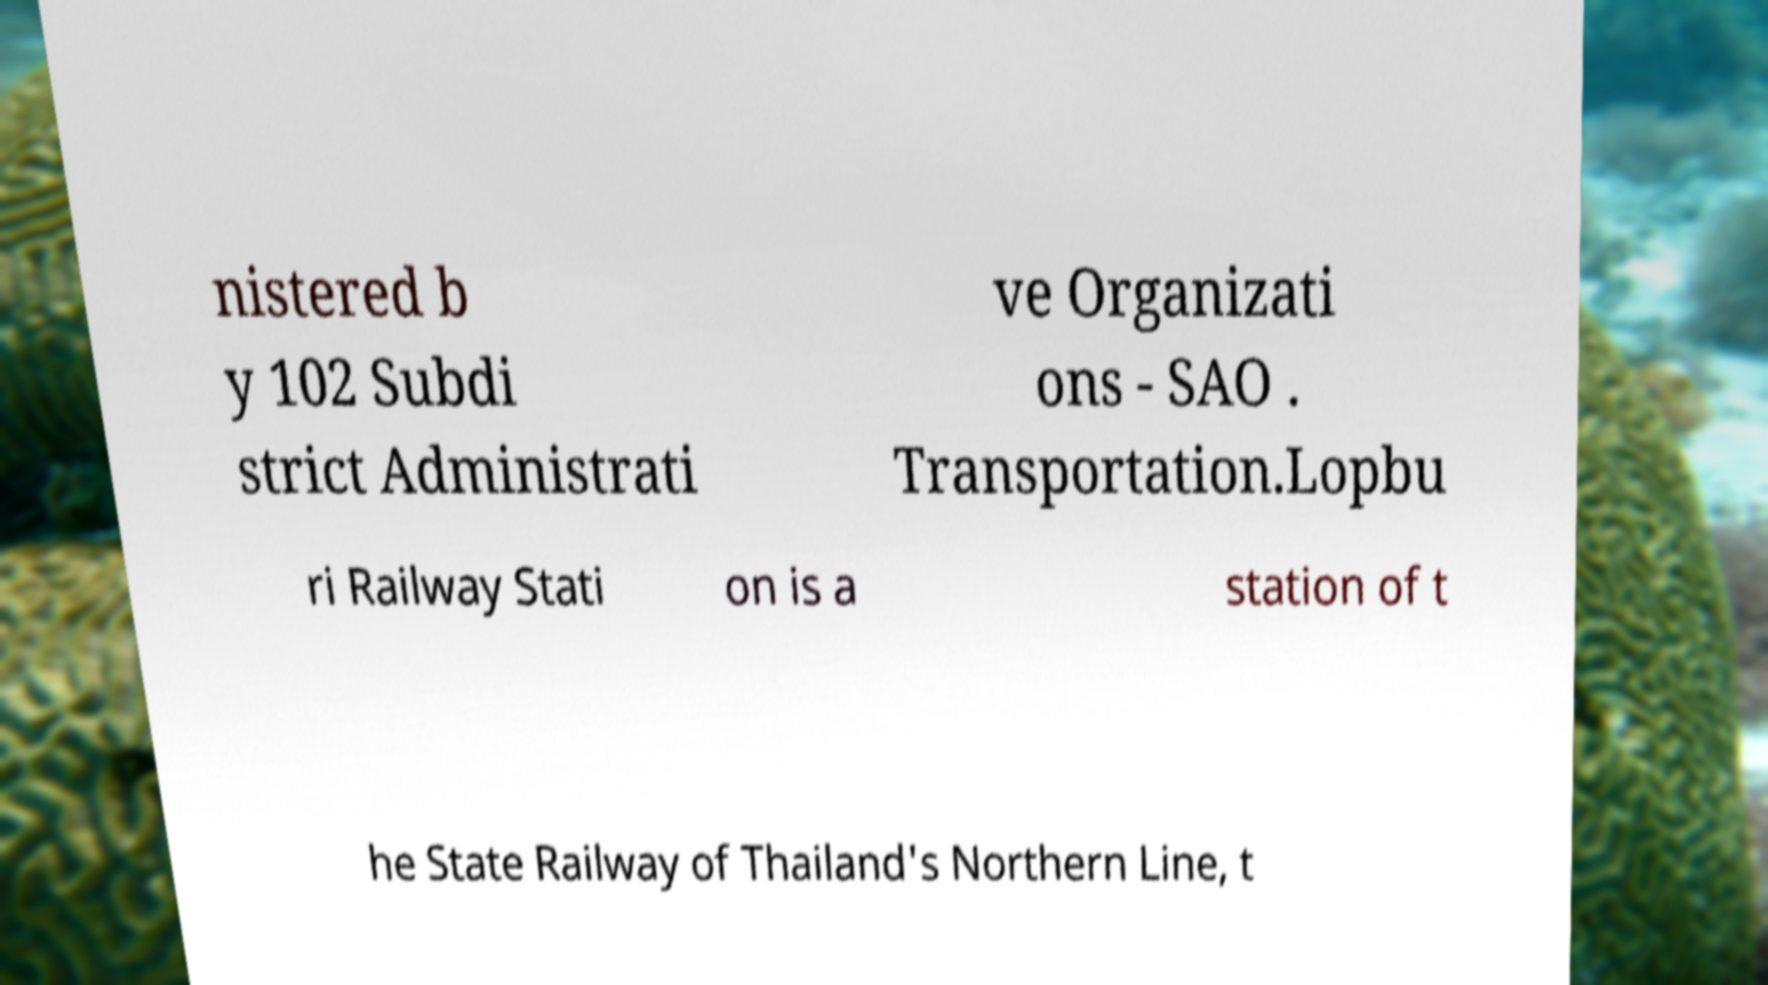For documentation purposes, I need the text within this image transcribed. Could you provide that? nistered b y 102 Subdi strict Administrati ve Organizati ons - SAO . Transportation.Lopbu ri Railway Stati on is a station of t he State Railway of Thailand's Northern Line, t 